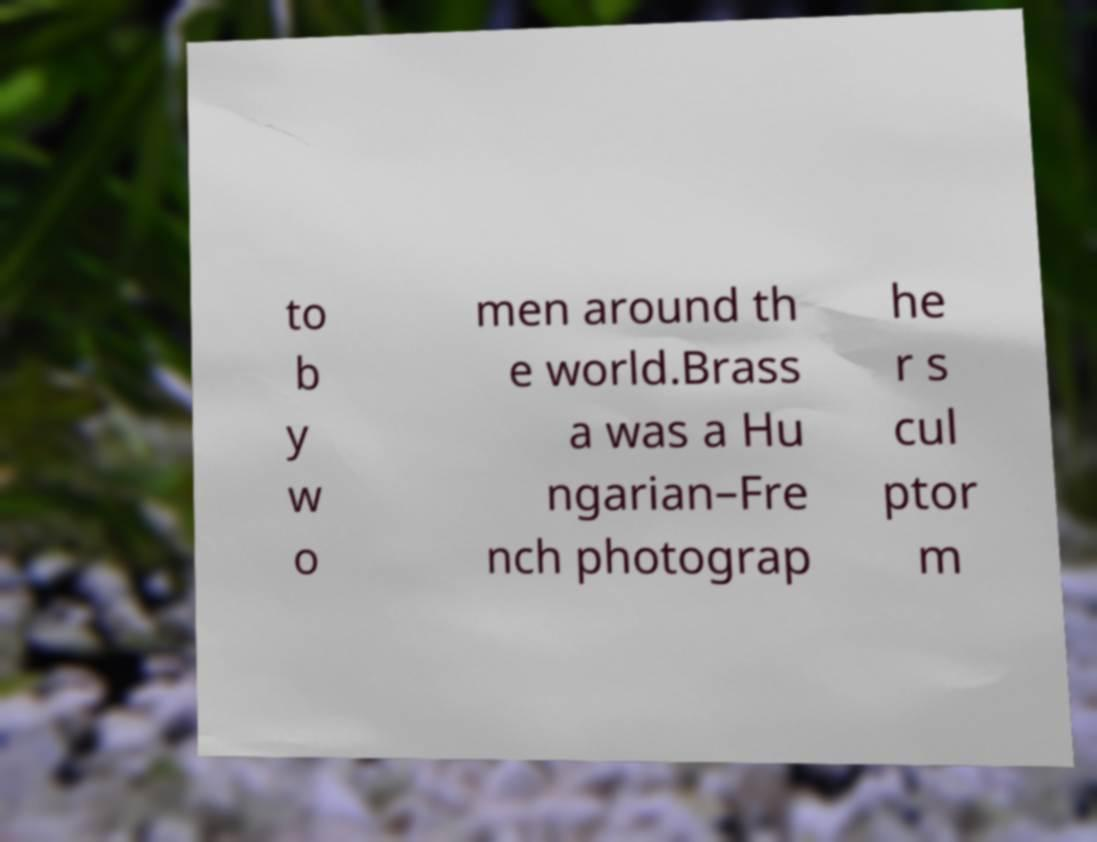What messages or text are displayed in this image? I need them in a readable, typed format. to b y w o men around th e world.Brass a was a Hu ngarian–Fre nch photograp he r s cul ptor m 